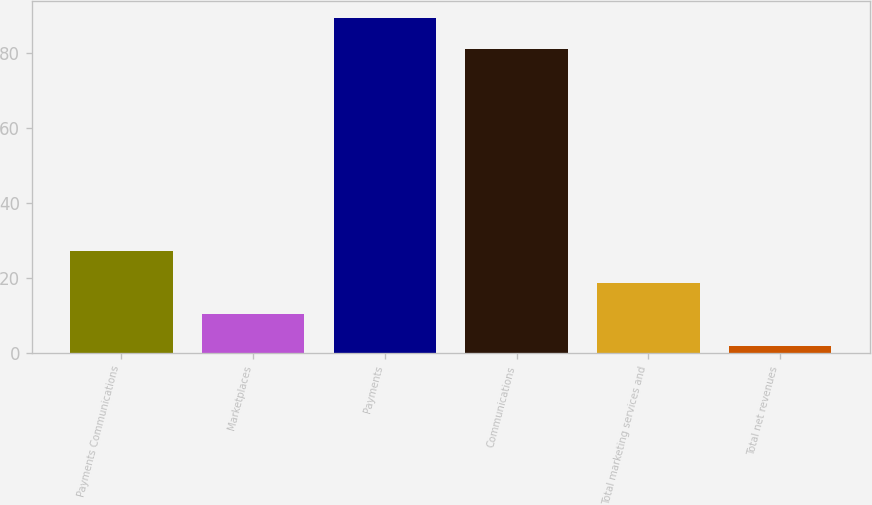Convert chart. <chart><loc_0><loc_0><loc_500><loc_500><bar_chart><fcel>Payments Communications<fcel>Marketplaces<fcel>Payments<fcel>Communications<fcel>Total marketing services and<fcel>Total net revenues<nl><fcel>27.2<fcel>10.4<fcel>89.4<fcel>81<fcel>18.8<fcel>2<nl></chart> 